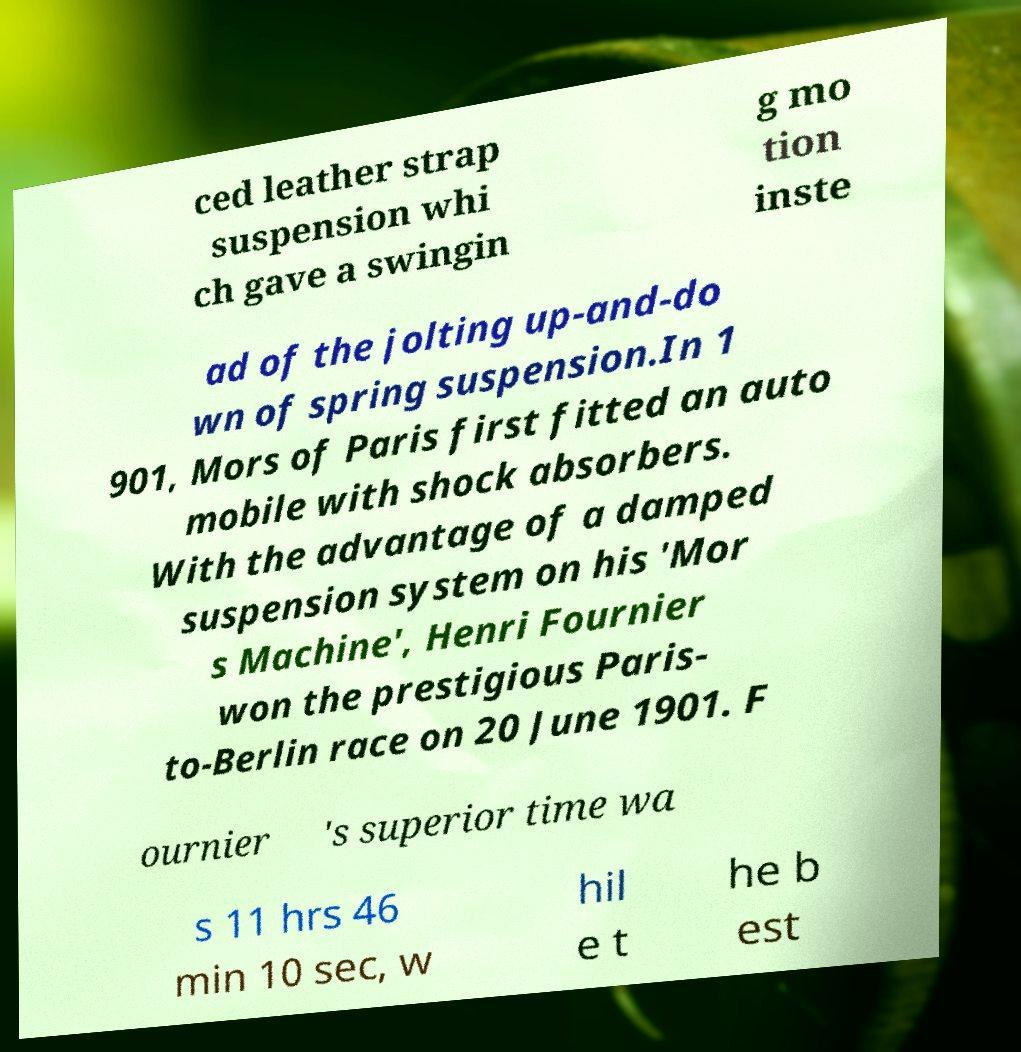Can you read and provide the text displayed in the image?This photo seems to have some interesting text. Can you extract and type it out for me? ced leather strap suspension whi ch gave a swingin g mo tion inste ad of the jolting up-and-do wn of spring suspension.In 1 901, Mors of Paris first fitted an auto mobile with shock absorbers. With the advantage of a damped suspension system on his 'Mor s Machine', Henri Fournier won the prestigious Paris- to-Berlin race on 20 June 1901. F ournier 's superior time wa s 11 hrs 46 min 10 sec, w hil e t he b est 